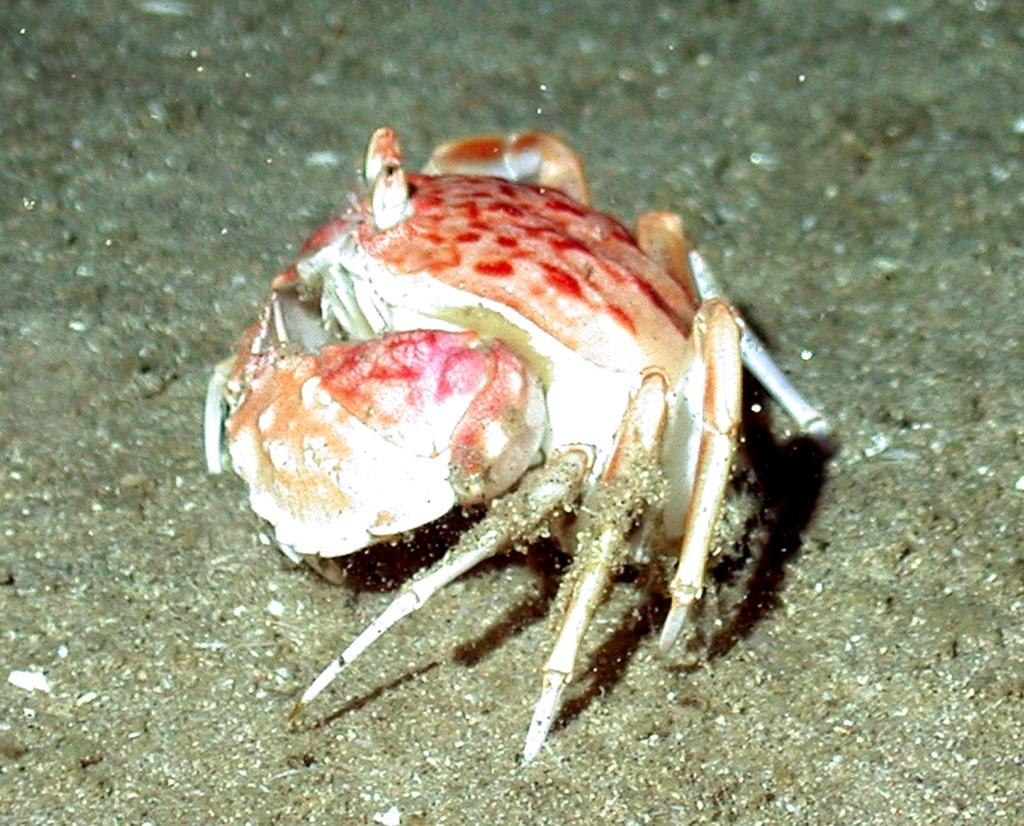What type of environment is shown in the image? The image depicts an underwater environment. Can you identify any specific creatures in the image? Yes, there is a crab in the middle of the image. What type of yarn is being used to create the underwater scene in the image? There is no yarn present in the image, as it is a photograph or illustration of an underwater environment. 